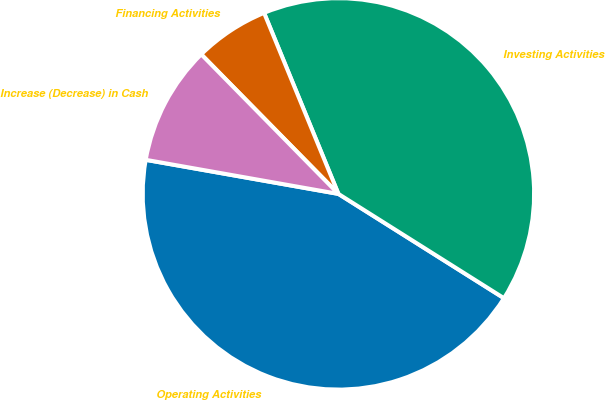Convert chart to OTSL. <chart><loc_0><loc_0><loc_500><loc_500><pie_chart><fcel>Operating Activities<fcel>Investing Activities<fcel>Financing Activities<fcel>Increase (Decrease) in Cash<nl><fcel>43.84%<fcel>40.15%<fcel>6.16%<fcel>9.85%<nl></chart> 